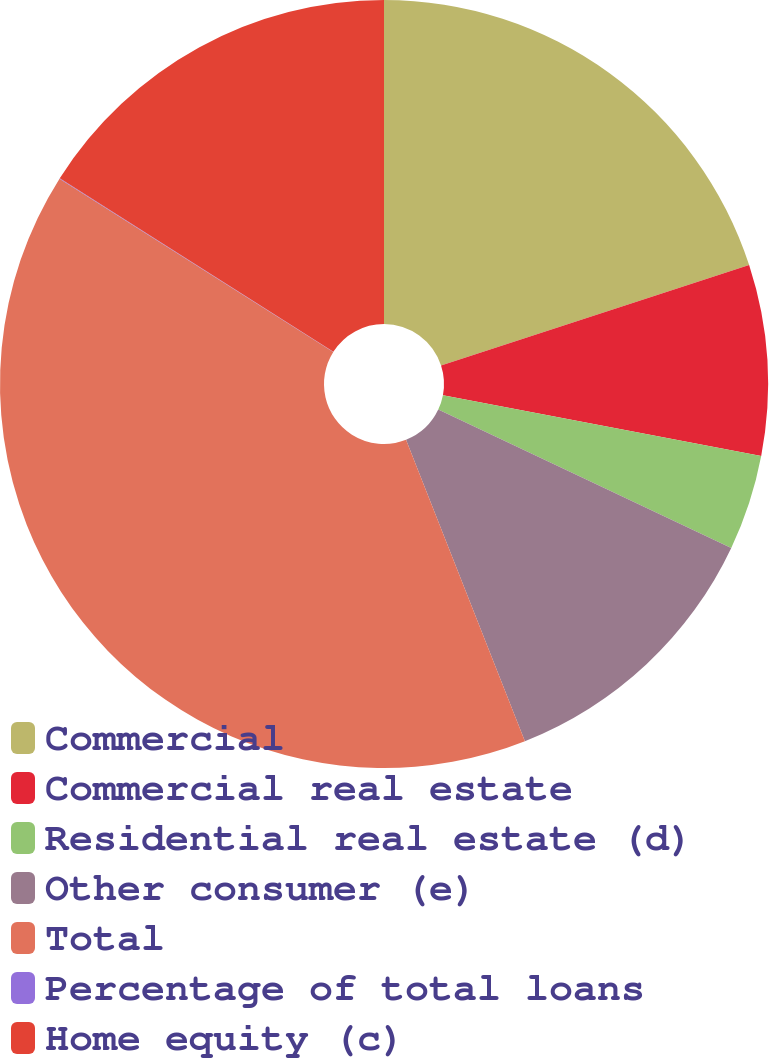Convert chart to OTSL. <chart><loc_0><loc_0><loc_500><loc_500><pie_chart><fcel>Commercial<fcel>Commercial real estate<fcel>Residential real estate (d)<fcel>Other consumer (e)<fcel>Total<fcel>Percentage of total loans<fcel>Home equity (c)<nl><fcel>19.99%<fcel>8.01%<fcel>4.02%<fcel>12.0%<fcel>39.96%<fcel>0.02%<fcel>16.0%<nl></chart> 